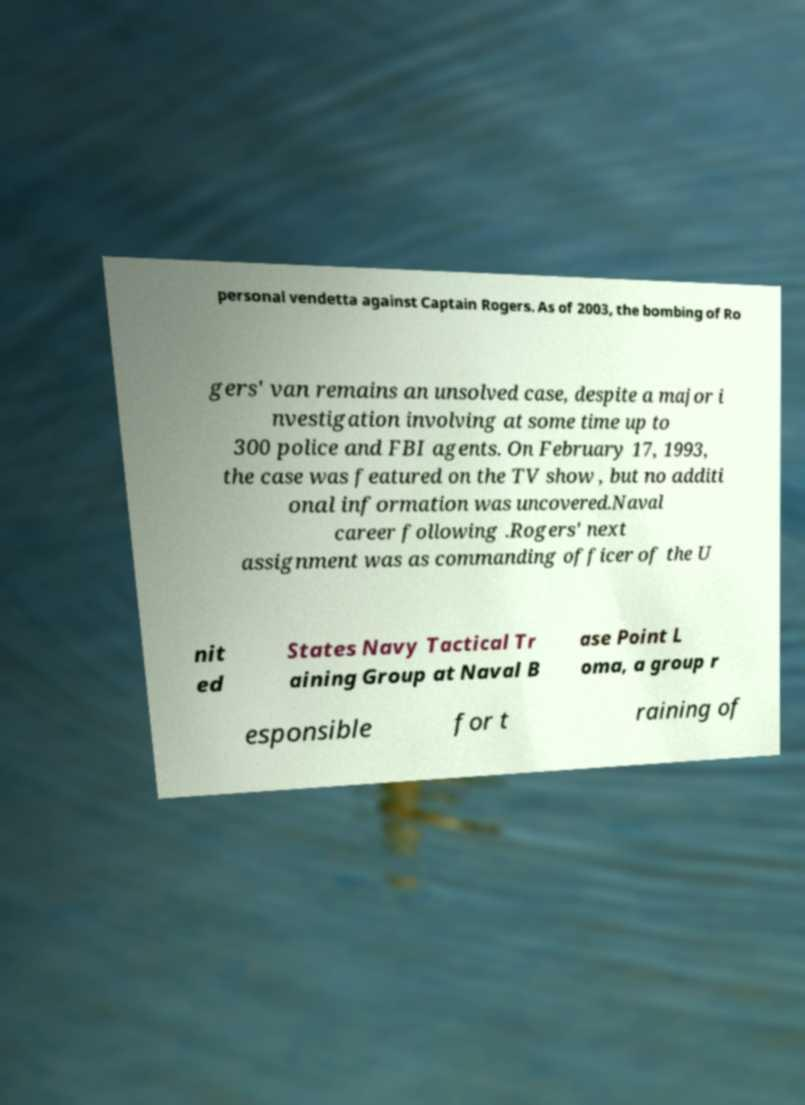There's text embedded in this image that I need extracted. Can you transcribe it verbatim? personal vendetta against Captain Rogers. As of 2003, the bombing of Ro gers' van remains an unsolved case, despite a major i nvestigation involving at some time up to 300 police and FBI agents. On February 17, 1993, the case was featured on the TV show , but no additi onal information was uncovered.Naval career following .Rogers' next assignment was as commanding officer of the U nit ed States Navy Tactical Tr aining Group at Naval B ase Point L oma, a group r esponsible for t raining of 